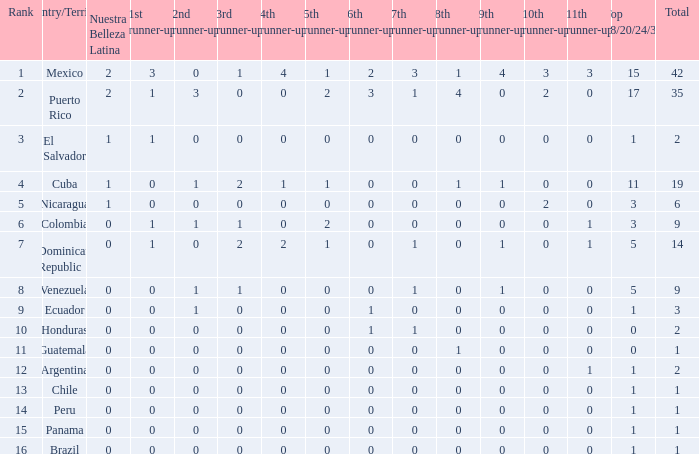What is the average total of the country with a 4th runner-up of 0 and a Nuestra Bellaza Latina less than 0? None. 